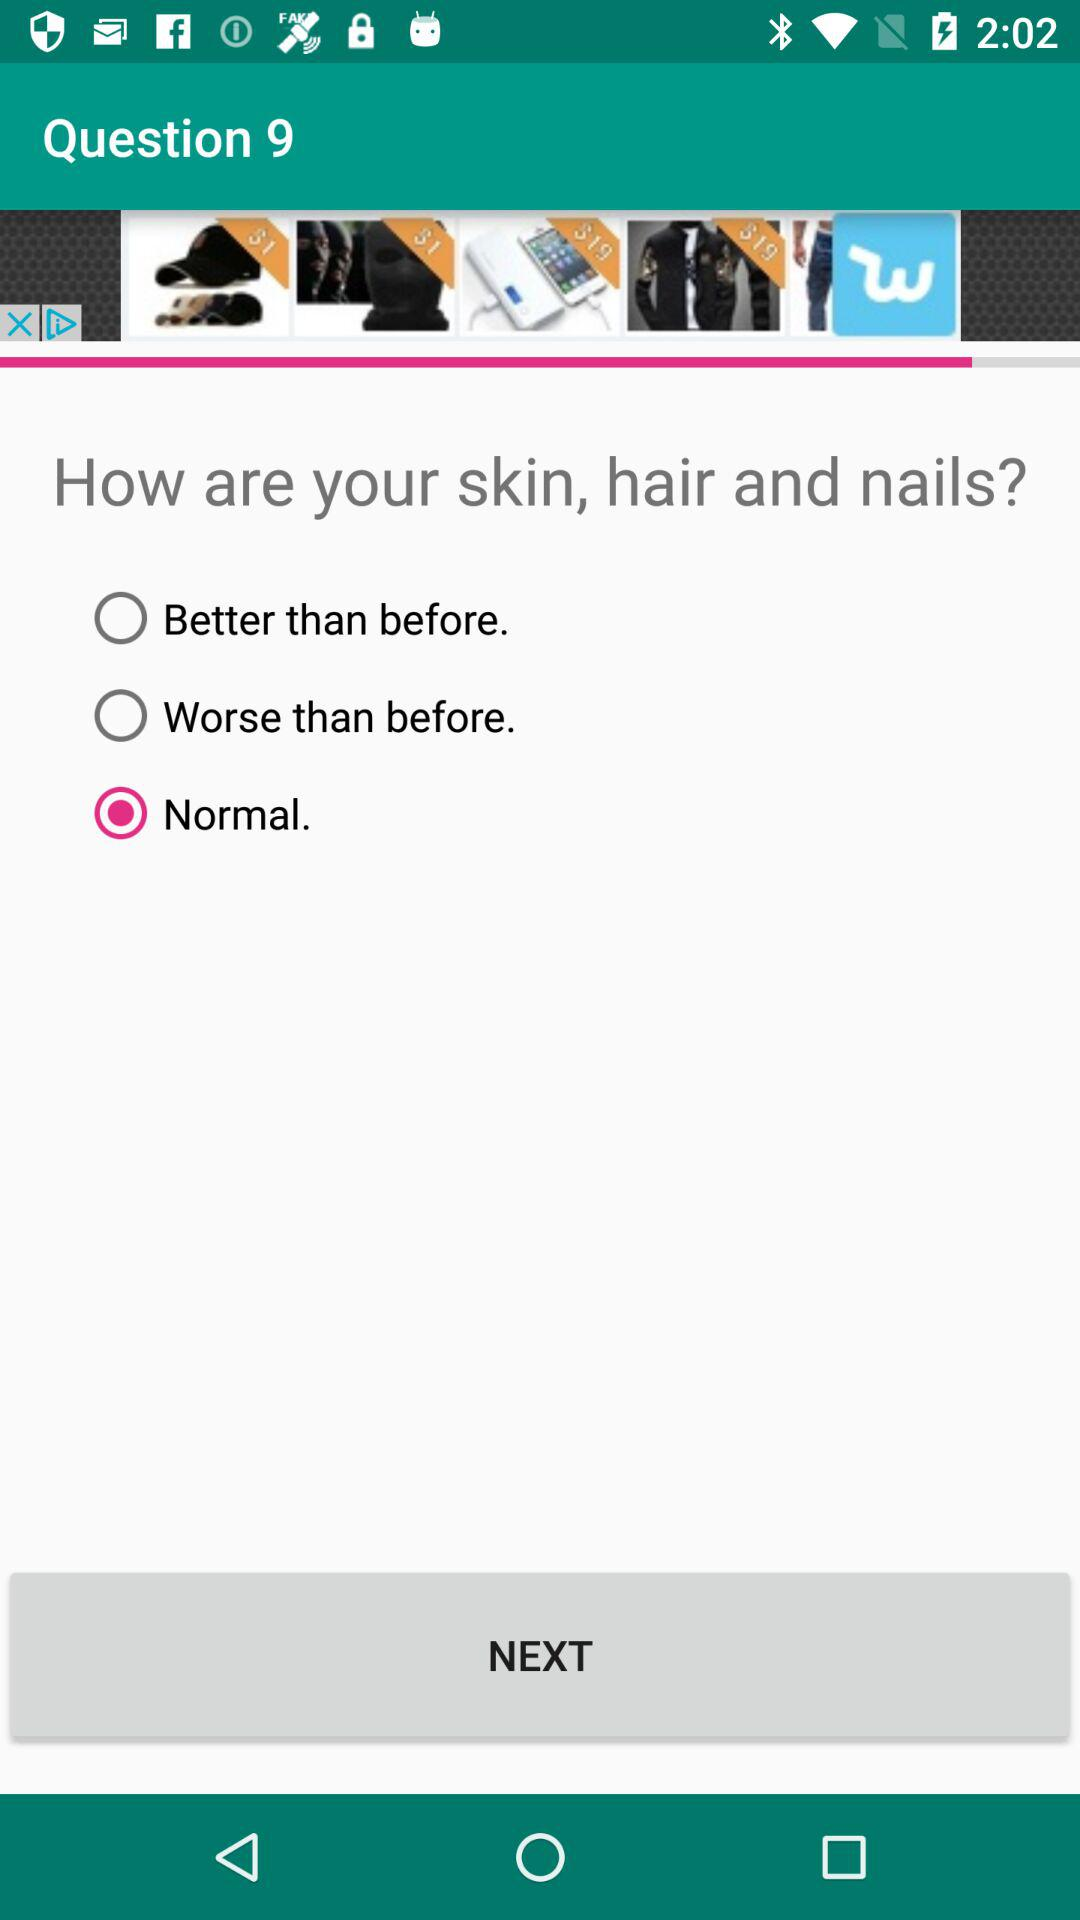What is the number of the question? The number of the question is 9. 